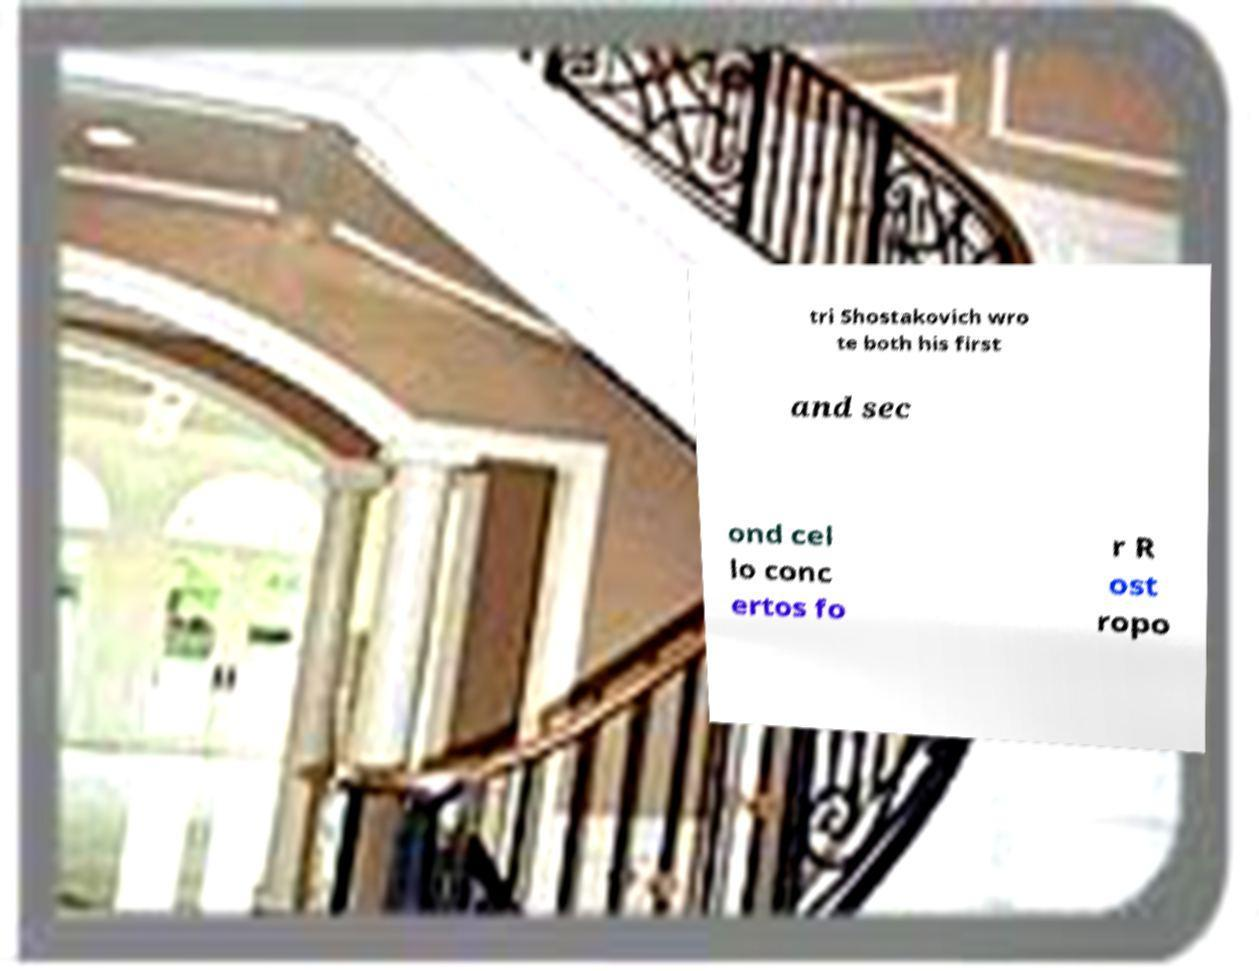Can you accurately transcribe the text from the provided image for me? tri Shostakovich wro te both his first and sec ond cel lo conc ertos fo r R ost ropo 